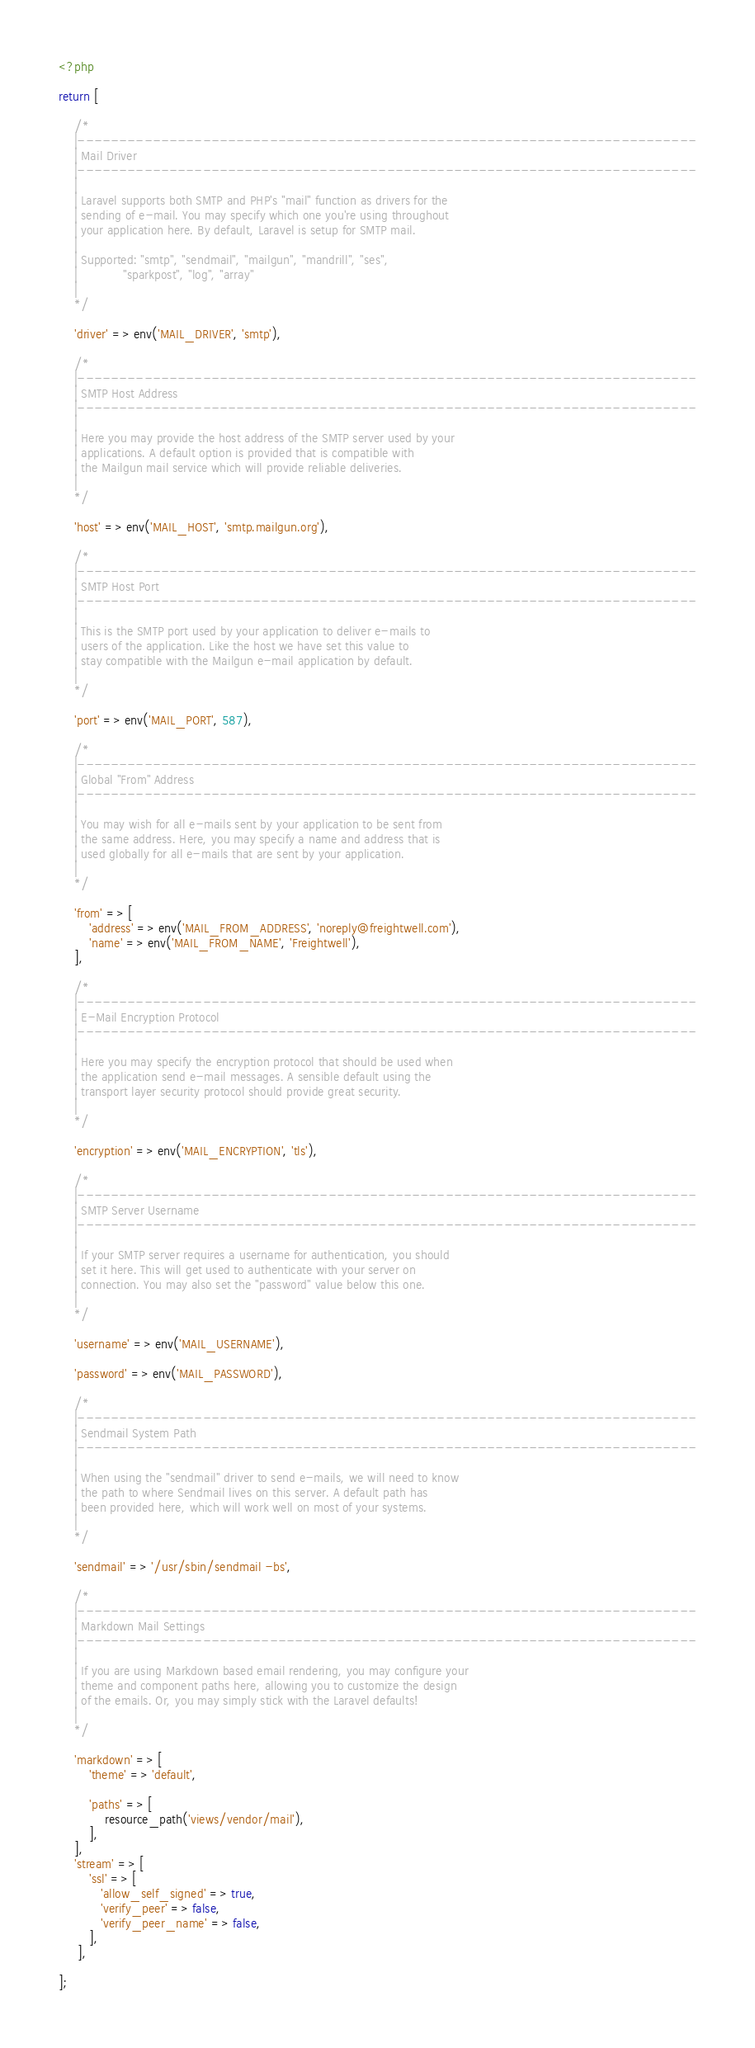<code> <loc_0><loc_0><loc_500><loc_500><_PHP_><?php

return [

    /*
    |--------------------------------------------------------------------------
    | Mail Driver
    |--------------------------------------------------------------------------
    |
    | Laravel supports both SMTP and PHP's "mail" function as drivers for the
    | sending of e-mail. You may specify which one you're using throughout
    | your application here. By default, Laravel is setup for SMTP mail.
    |
    | Supported: "smtp", "sendmail", "mailgun", "mandrill", "ses",
    |            "sparkpost", "log", "array"
    |
    */

    'driver' => env('MAIL_DRIVER', 'smtp'),

    /*
    |--------------------------------------------------------------------------
    | SMTP Host Address
    |--------------------------------------------------------------------------
    |
    | Here you may provide the host address of the SMTP server used by your
    | applications. A default option is provided that is compatible with
    | the Mailgun mail service which will provide reliable deliveries.
    |
    */

    'host' => env('MAIL_HOST', 'smtp.mailgun.org'),

    /*
    |--------------------------------------------------------------------------
    | SMTP Host Port
    |--------------------------------------------------------------------------
    |
    | This is the SMTP port used by your application to deliver e-mails to
    | users of the application. Like the host we have set this value to
    | stay compatible with the Mailgun e-mail application by default.
    |
    */

    'port' => env('MAIL_PORT', 587),

    /*
    |--------------------------------------------------------------------------
    | Global "From" Address
    |--------------------------------------------------------------------------
    |
    | You may wish for all e-mails sent by your application to be sent from
    | the same address. Here, you may specify a name and address that is
    | used globally for all e-mails that are sent by your application.
    |
    */

    'from' => [
        'address' => env('MAIL_FROM_ADDRESS', 'noreply@freightwell.com'),
        'name' => env('MAIL_FROM_NAME', 'Freightwell'),
    ],

    /*
    |--------------------------------------------------------------------------
    | E-Mail Encryption Protocol
    |--------------------------------------------------------------------------
    |
    | Here you may specify the encryption protocol that should be used when
    | the application send e-mail messages. A sensible default using the
    | transport layer security protocol should provide great security.
    |
    */

    'encryption' => env('MAIL_ENCRYPTION', 'tls'),

    /*
    |--------------------------------------------------------------------------
    | SMTP Server Username
    |--------------------------------------------------------------------------
    |
    | If your SMTP server requires a username for authentication, you should
    | set it here. This will get used to authenticate with your server on
    | connection. You may also set the "password" value below this one.
    |
    */

    'username' => env('MAIL_USERNAME'),

    'password' => env('MAIL_PASSWORD'),

    /*
    |--------------------------------------------------------------------------
    | Sendmail System Path
    |--------------------------------------------------------------------------
    |
    | When using the "sendmail" driver to send e-mails, we will need to know
    | the path to where Sendmail lives on this server. A default path has
    | been provided here, which will work well on most of your systems.
    |
    */

    'sendmail' => '/usr/sbin/sendmail -bs',

    /*
    |--------------------------------------------------------------------------
    | Markdown Mail Settings
    |--------------------------------------------------------------------------
    |
    | If you are using Markdown based email rendering, you may configure your
    | theme and component paths here, allowing you to customize the design
    | of the emails. Or, you may simply stick with the Laravel defaults!
    |
    */

    'markdown' => [
        'theme' => 'default',

        'paths' => [
            resource_path('views/vendor/mail'),
        ],
    ],
    'stream' => [
        'ssl' => [
           'allow_self_signed' => true,
           'verify_peer' => false,
           'verify_peer_name' => false,
        ],
     ],

];
</code> 